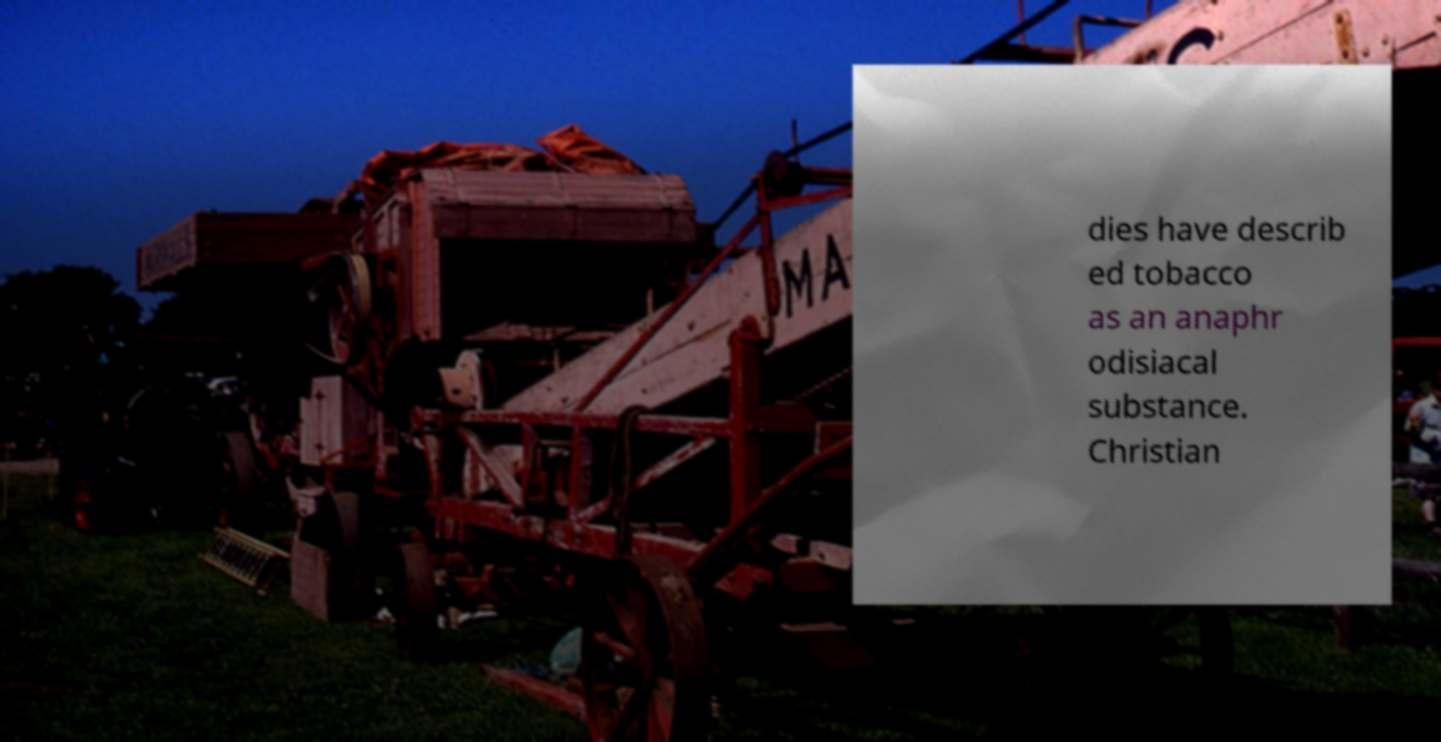Can you read and provide the text displayed in the image?This photo seems to have some interesting text. Can you extract and type it out for me? dies have describ ed tobacco as an anaphr odisiacal substance. Christian 